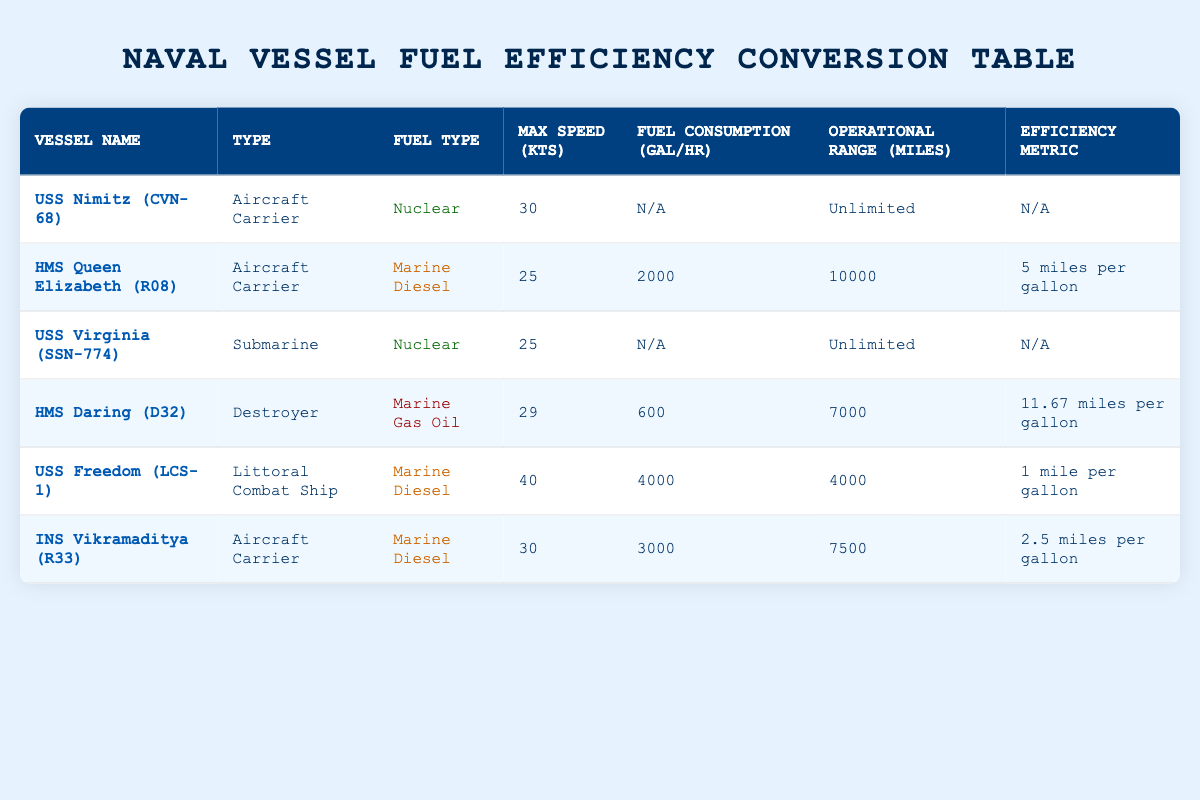What is the fuel type of the USS Nimitz (CVN-68)? The table states that the fuel type for the USS Nimitz (CVN-68) is "Nuclear". Therefore, I can directly refer to the corresponding row under the "Fuel Type" column.
Answer: Nuclear Which vessel has the highest maximum speed? By reviewing the "Max Speed (kts)" column, I find that the USS Freedom (LCS-1) has the highest maximum speed of 40 knots compared to the other vessels.
Answer: USS Freedom (LCS-1) Is the fuel consumption for the USS Virginia (SSN-774) provided in the table? Checking the "Fuel Consumption (gal/hr)" column, the value for USS Virginia (SSN-774) is listed as "N/A", indicating that the fuel consumption data is not available.
Answer: No What is the operational range of HMS Daring (D32)? The operational range for HMS Daring (D32) is listed under the "Operational Range (miles)" column, where it states "7000". Thus, I can directly cite this information.
Answer: 7000 If the operational range of HMS Queen Elizabeth (R08) is 10000 miles, how many miles can it travel per gallon based on its efficiency metric? The efficiency metric for HMS Queen Elizabeth (R08) is "5 miles per gallon". To determine how far it can go on 10000 miles, I can multiply: 10000 miles / 5 miles per gallon = 2000 gallons. So, it shows that things correlate in terms of usage per the range.
Answer: 2000 gallons Which vessel uses Marine Gas Oil as its fuel type, and what is its efficiency metric? The vessel that uses Marine Gas Oil is HMS Daring (D32). According to the table, its efficiency metric states "11.67 miles per gallon", which I find under the relevant columns.
Answer: HMS Daring (D32); 11.67 miles per gallon What is the average maximum speed of all the vessels listed? To calculate the average maximum speed, I sum the maximum speeds of the vessels with provided speeds: 30 (Nimitz) + 25 (Queen Elizabeth) + 25 (Virginia) + 29 (Daring) + 40 (Freedom) + 30 (Vikramaditya) = 179. There are 6 vessels, so the average is 179 / 6 ≈ 29.83 knots.
Answer: 29.83 knots Are there any vessels in the table that have an unlimited operational range? By inspecting the "Operational Range (miles)" column, USS Nimitz (CVN-68) and USS Virginia (SSN-774) both have an operational range labeled as "Unlimited". Thus, this statement holds true for these vessels.
Answer: Yes 